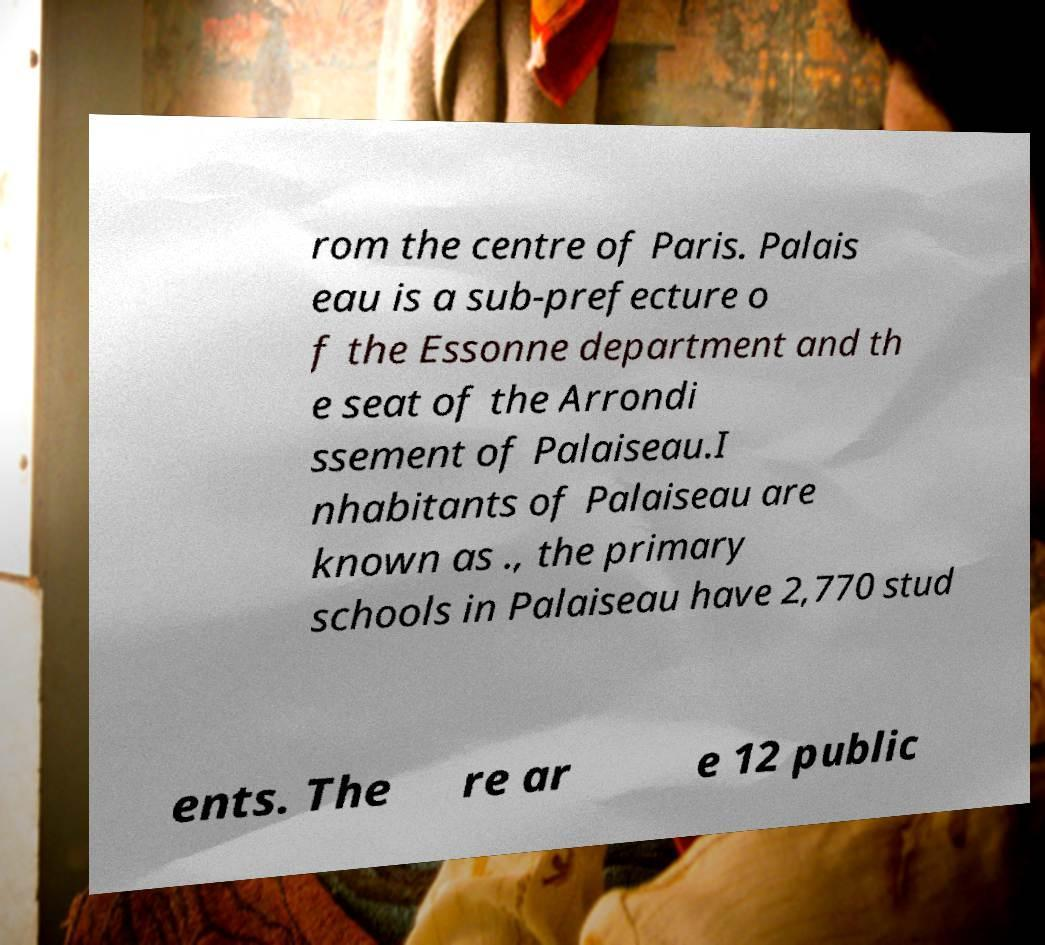Can you read and provide the text displayed in the image?This photo seems to have some interesting text. Can you extract and type it out for me? rom the centre of Paris. Palais eau is a sub-prefecture o f the Essonne department and th e seat of the Arrondi ssement of Palaiseau.I nhabitants of Palaiseau are known as ., the primary schools in Palaiseau have 2,770 stud ents. The re ar e 12 public 